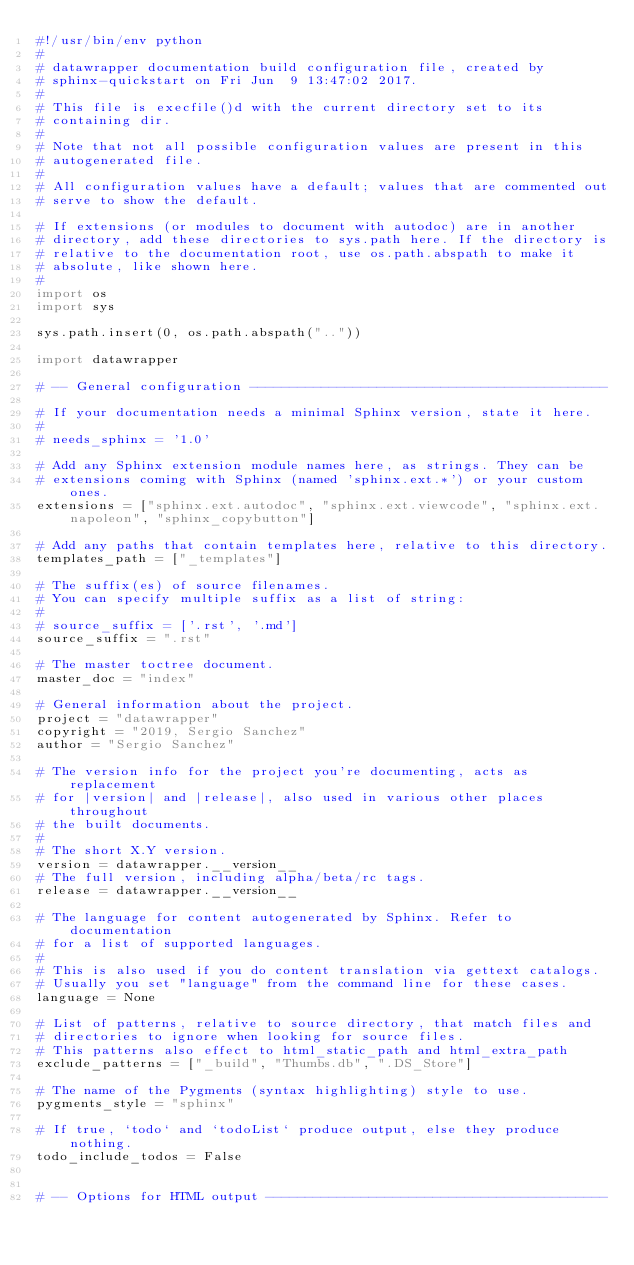<code> <loc_0><loc_0><loc_500><loc_500><_Python_>#!/usr/bin/env python
#
# datawrapper documentation build configuration file, created by
# sphinx-quickstart on Fri Jun  9 13:47:02 2017.
#
# This file is execfile()d with the current directory set to its
# containing dir.
#
# Note that not all possible configuration values are present in this
# autogenerated file.
#
# All configuration values have a default; values that are commented out
# serve to show the default.

# If extensions (or modules to document with autodoc) are in another
# directory, add these directories to sys.path here. If the directory is
# relative to the documentation root, use os.path.abspath to make it
# absolute, like shown here.
#
import os
import sys

sys.path.insert(0, os.path.abspath(".."))

import datawrapper

# -- General configuration ---------------------------------------------

# If your documentation needs a minimal Sphinx version, state it here.
#
# needs_sphinx = '1.0'

# Add any Sphinx extension module names here, as strings. They can be
# extensions coming with Sphinx (named 'sphinx.ext.*') or your custom ones.
extensions = ["sphinx.ext.autodoc", "sphinx.ext.viewcode", "sphinx.ext.napoleon", "sphinx_copybutton"]

# Add any paths that contain templates here, relative to this directory.
templates_path = ["_templates"]

# The suffix(es) of source filenames.
# You can specify multiple suffix as a list of string:
#
# source_suffix = ['.rst', '.md']
source_suffix = ".rst"

# The master toctree document.
master_doc = "index"

# General information about the project.
project = "datawrapper"
copyright = "2019, Sergio Sanchez"
author = "Sergio Sanchez"

# The version info for the project you're documenting, acts as replacement
# for |version| and |release|, also used in various other places throughout
# the built documents.
#
# The short X.Y version.
version = datawrapper.__version__
# The full version, including alpha/beta/rc tags.
release = datawrapper.__version__

# The language for content autogenerated by Sphinx. Refer to documentation
# for a list of supported languages.
#
# This is also used if you do content translation via gettext catalogs.
# Usually you set "language" from the command line for these cases.
language = None

# List of patterns, relative to source directory, that match files and
# directories to ignore when looking for source files.
# This patterns also effect to html_static_path and html_extra_path
exclude_patterns = ["_build", "Thumbs.db", ".DS_Store"]

# The name of the Pygments (syntax highlighting) style to use.
pygments_style = "sphinx"

# If true, `todo` and `todoList` produce output, else they produce nothing.
todo_include_todos = False


# -- Options for HTML output -------------------------------------------
</code> 